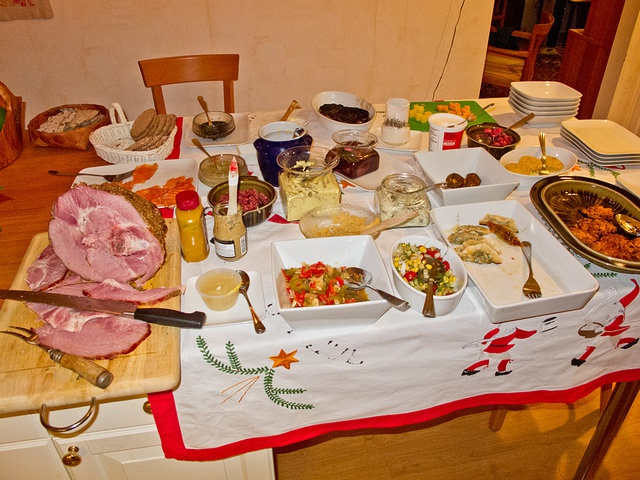Describe the objects in this image and their specific colors. I can see dining table in maroon, tan, lightgray, and brown tones, bowl in maroon, lightgray, darkgray, and olive tones, chair in maroon, tan, and brown tones, bowl in maroon, brown, and salmon tones, and bowl in maroon, tan, darkgray, and lightgray tones in this image. 